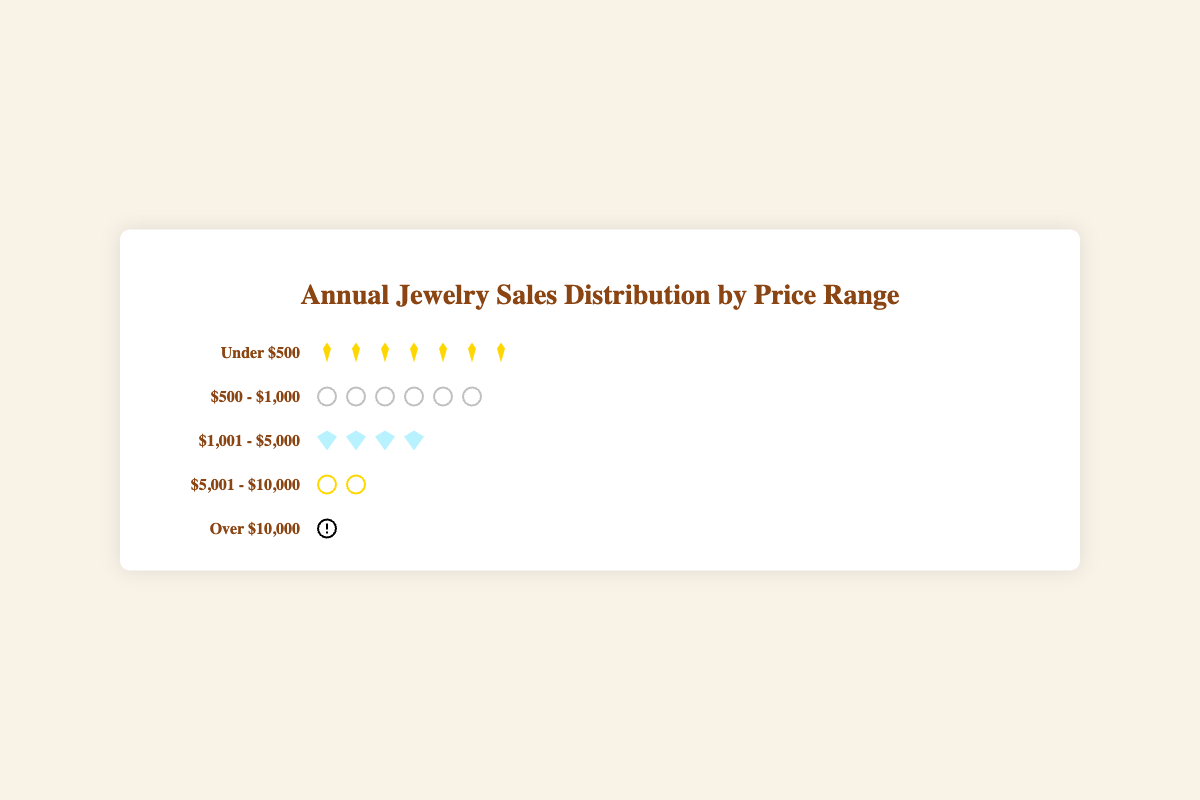What is the price range with the highest number of sales? The figure shows different price ranges with icons representing the number of sales. The price range with the most icons is "Under $500", indicating it has the highest number of sales.
Answer: Under $500 How many sales are there in the "$500 - $1,000" price range? The icons next to the "$500 - $1,000" price range represent the sales. Counting them gives six icons, where each icon represents 50 sales (since 6 icons * 50 = 300 sales).
Answer: 300 What is the total number of sales across all price ranges? Sum the sales numbers for each price range: 350 (Under $500) + 280 ($500 - $1,000) + 175 ($1,001 - $5,000) + 90 ($5,001 - $10,000) + 45 (Over $10,000). The total is 350 + 280 + 175 + 90 + 45 = 940.
Answer: 940 Which price range has the least number of sales and how many? The price range with the fewest icons is "Over $10,000". Counting the icons, there is only one, representing 45 sales.
Answer: Over $10,000, 45 Compare the number of sales between the "$1,001 - $5,000" and "$5,001 - $10,000" ranges. Which has more? The "$1,001 - $5,000" range has 175 sales, while the "$5,001 - $10,000" range has 90 sales. Therefore, "$1,001 - $5,000" has more sales.
Answer: $1,001 - $5,000 What is the total number of sales for items priced above $1,000? Sum the sales numbers for the ranges "$1,001 - $5,000", "$5,001 - $10,000", and "Over $10,000": 175 + 90 + 45 = 310.
Answer: 310 How many times more sales does the "Under $500" range have compared to the "Over $10,000" range? The "Under $500" range has 350 sales, and the "Over $10,000" range has 45 sales. Divide 350 by 45 to find how many times more: 350 / 45 ≈ 7.78.
Answer: 7.78 What percentage of the total sales does the "$500 - $1,000" range constitute? First, find the total sales: 350 + 280 + 175 + 90 + 45 = 940. The "$500 - $1,000" range has 280 sales. To find the percentage: (280 / 940) * 100 ≈ 29.79%.
Answer: 29.79% If each icon in any range represents 50 sales, how many icons should be there for the "Under $500" range? Each icon represents 50 sales. The "Under $500" range has 350 sales. So the number of icons should be 350 / 50 = 7.
Answer: 7 